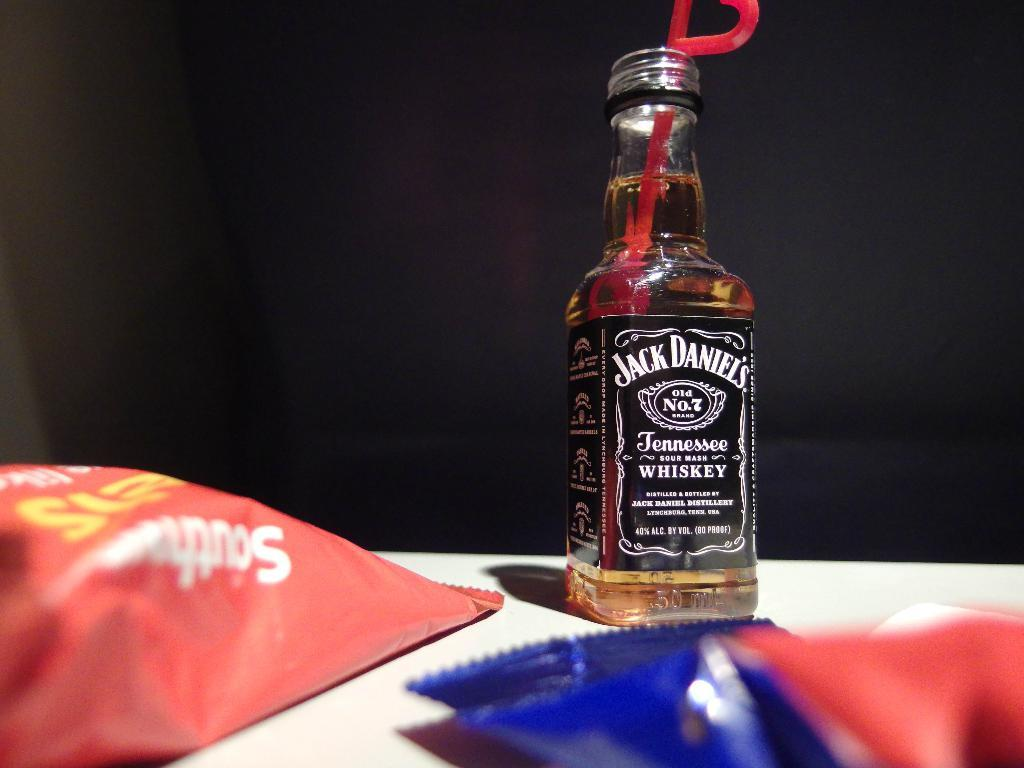What type of beverage container is in the image? There is a wine bottle in the image. What type of snack is present in the image? Chips are present in the image. Where are the wine bottle and chips located? The wine bottle and chips are on a wooden table. What type of nut is being used to crack open the wine bottle in the image? There is no nut present in the image, nor is there any indication that the wine bottle is being opened. 